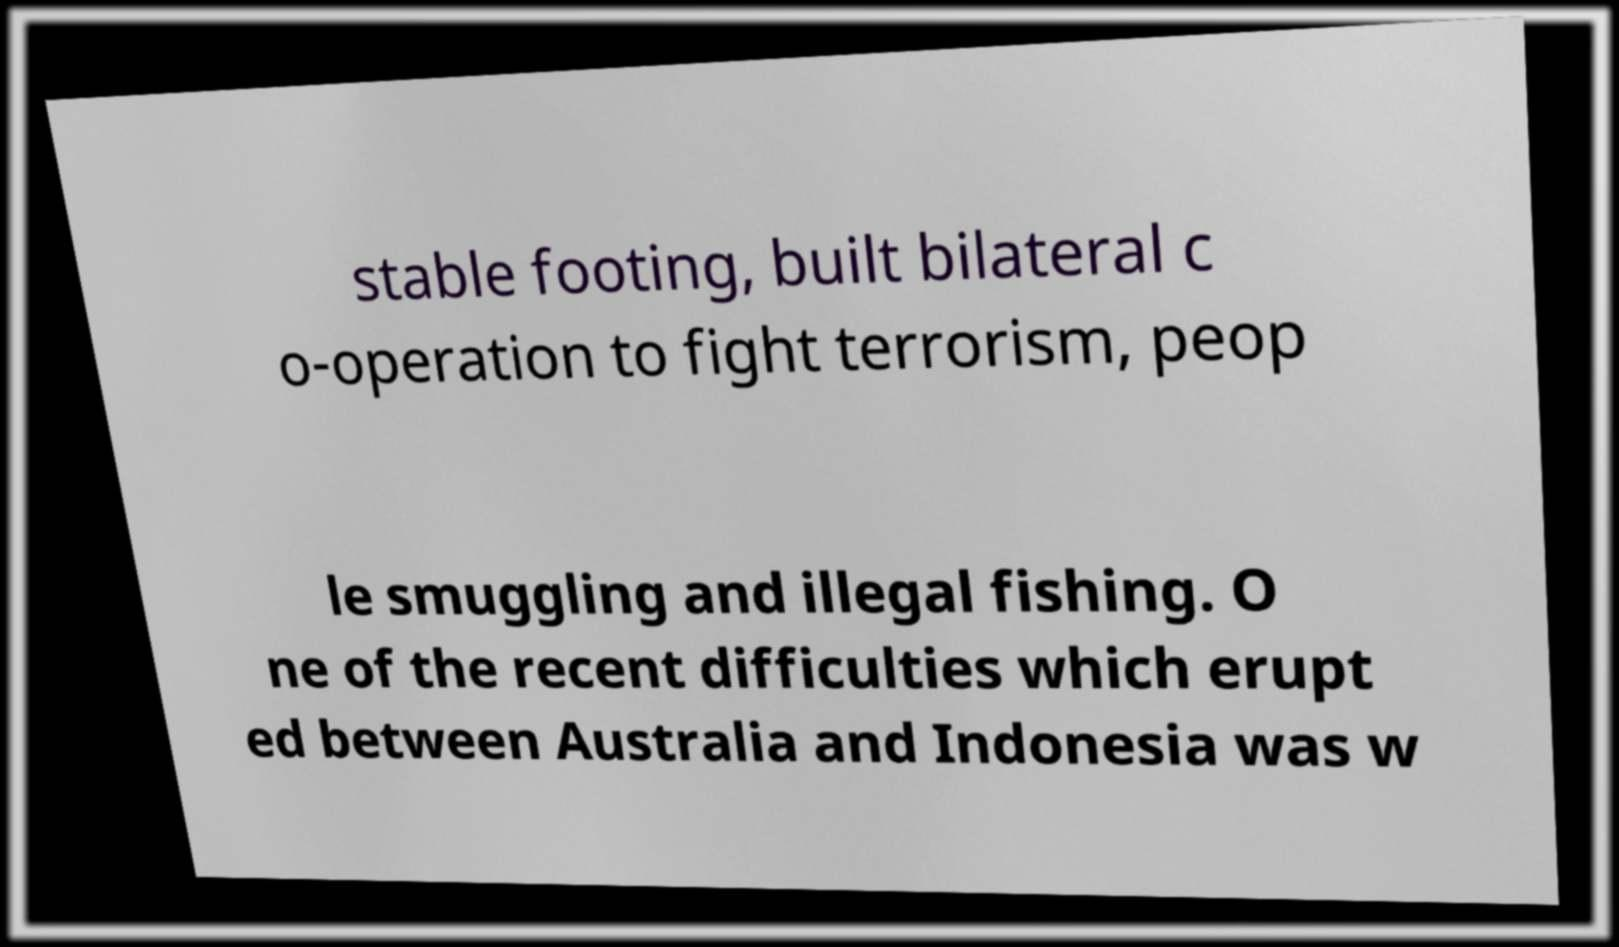I need the written content from this picture converted into text. Can you do that? stable footing, built bilateral c o-operation to fight terrorism, peop le smuggling and illegal fishing. O ne of the recent difficulties which erupt ed between Australia and Indonesia was w 